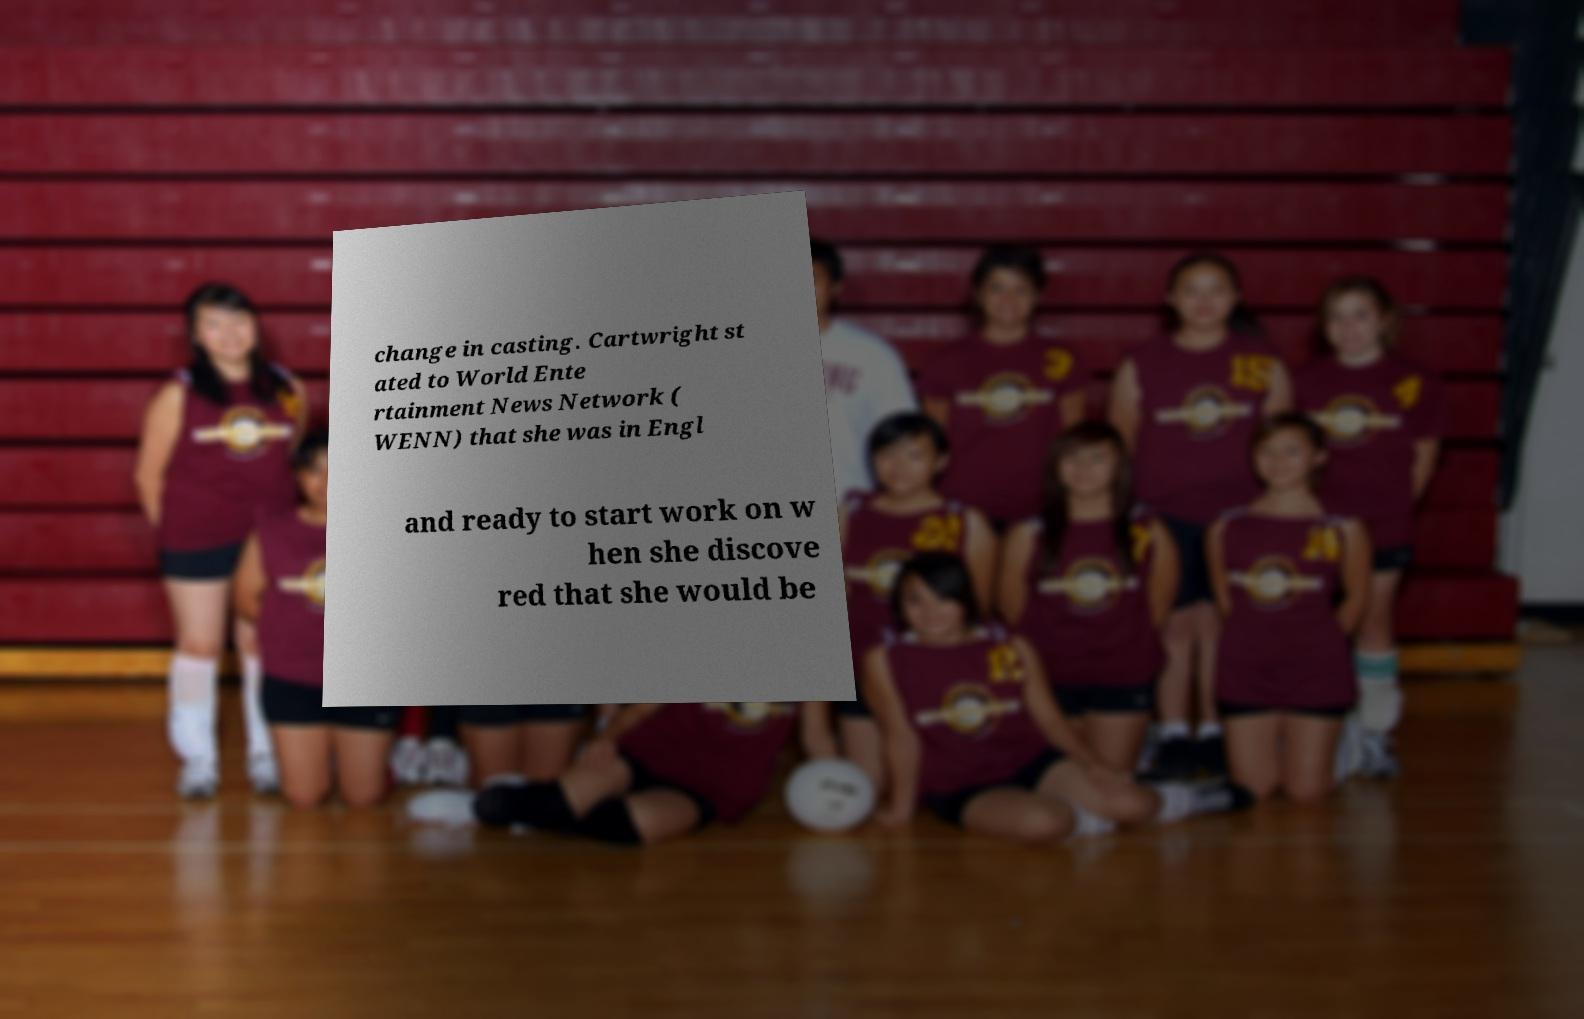What messages or text are displayed in this image? I need them in a readable, typed format. change in casting. Cartwright st ated to World Ente rtainment News Network ( WENN) that she was in Engl and ready to start work on w hen she discove red that she would be 